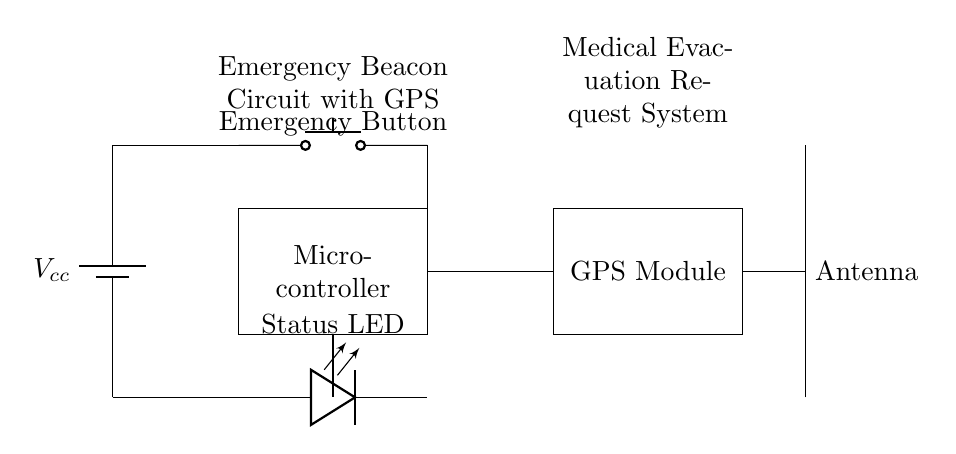What is the main component used to control the circuit? The main component is the microcontroller, as it is responsible for processing the input from the emergency button and GPS module.
Answer: microcontroller What is the purpose of the emergency button in the circuit? The emergency button initiates a medical evacuation request when pressed, allowing for immediate communication of the need for assistance.
Answer: medical evacuation request Which component indicates the status of the circuit? The status LED shows the operational state of the circuit, such as whether it is powered and functioning properly.
Answer: Status LED What type of module is integrated into the circuit for location tracking? The GPS module provides real-time location data, which is crucial for identifying the precise location of the medical emergency.
Answer: GPS module How many main connections are there between components in this circuit? There are six main connections: from the power supply to the microcontroller, from the emergency button to the microcontroller, from the microcontroller to the GPS module, from the GPS module to the antenna, and from the LED providing feedback.
Answer: six What does the antenna in the circuit do? The antenna enables the transmission of the GPS data, which is essential for relaying the medical evacuation request to the relevant responders.
Answer: transmission of data What is the power supply voltage denoted as in the circuit? The power supply voltage is labeled as Vcc, indicating the positive terminal of the battery providing power to the circuit.
Answer: Vcc 